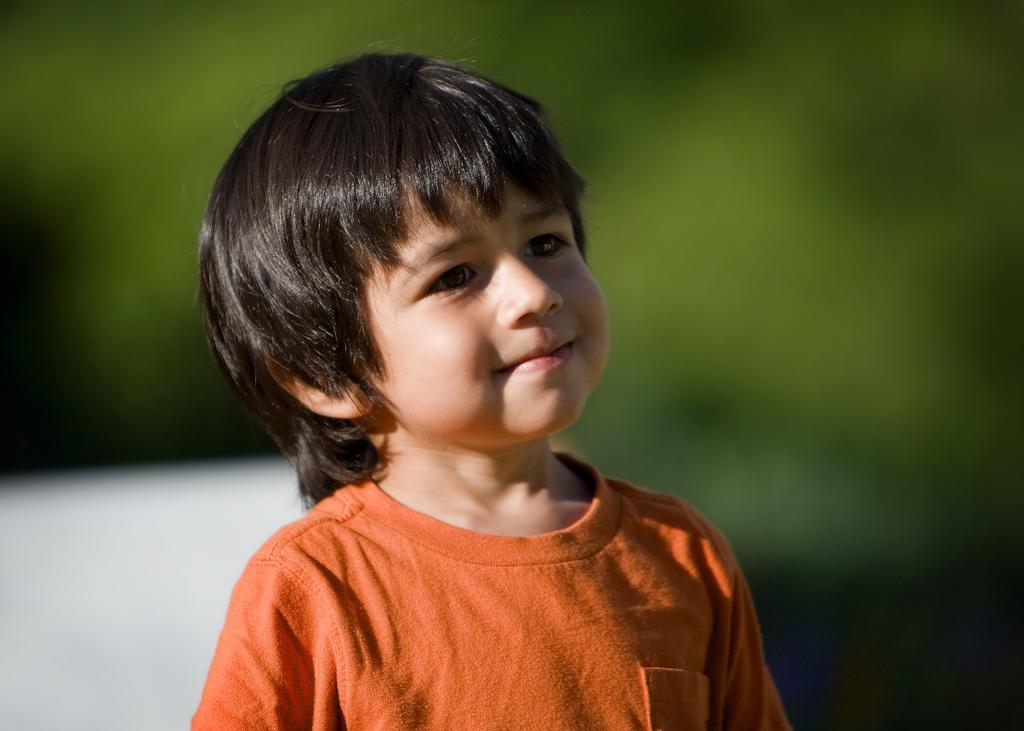Please provide a concise description of this image. In this image, we can see a kid is smiling and wearing orange t-shirt. Background there is a blur view. Here we can see green and white colors. 